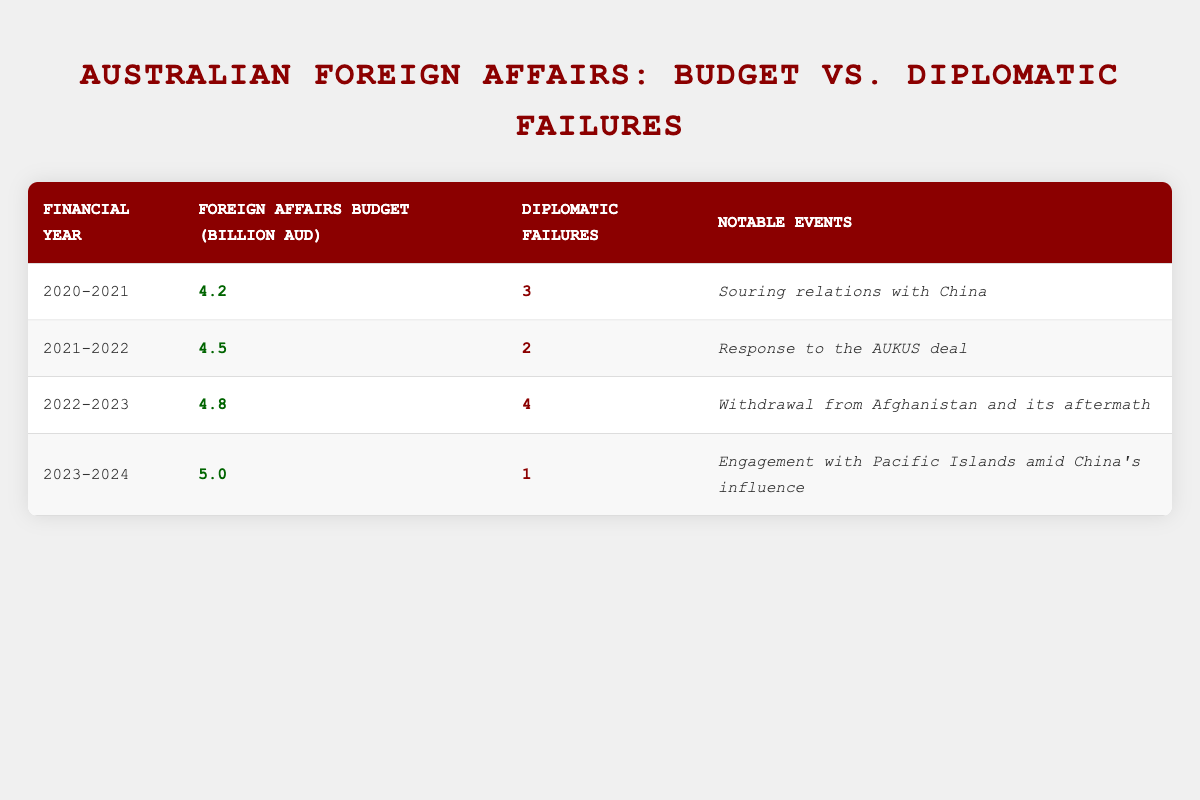What was the total foreign affairs budget for the financial year 2022-2023? The table states that the total foreign affairs budget for the financial year 2022-2023 is 4.8 billion AUD.
Answer: 4.8 billion AUD How many diplomatic failures were reported in the financial year 2021-2022? The table indicates that there were 2 diplomatic failures reported in the financial year 2021-2022.
Answer: 2 What is the difference in the total foreign affairs budget between the financial years 2020-2021 and 2023-2024? The budget for 2020-2021 is 4.2 billion AUD, and for 2023-2024 is 5.0 billion AUD. The difference is calculated as 5.0 - 4.2 = 0.8 billion AUD.
Answer: 0.8 billion AUD Was there a notable event related to Australia's foreign affairs in the financial year 2020-2021? Yes, the notable event was the souring of relations with China, as stated in the table for that financial year.
Answer: Yes What is the average number of diplomatic failures reported over the four financial years? To calculate the average, we sum the diplomatic failures: (3 + 2 + 4 + 1) = 10. There are 4 financial years, so the average is 10/4 = 2.5.
Answer: 2.5 